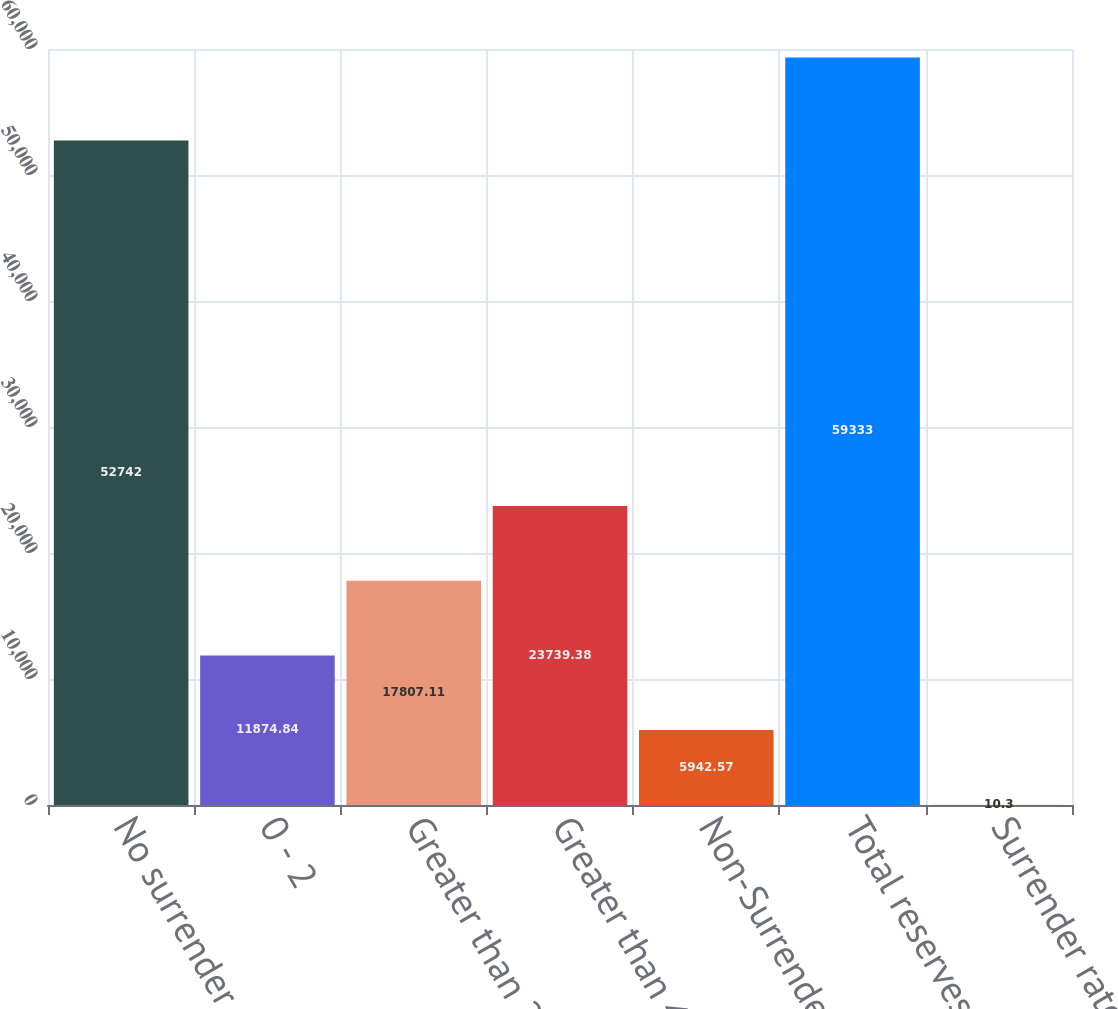Convert chart. <chart><loc_0><loc_0><loc_500><loc_500><bar_chart><fcel>No surrender charge<fcel>0 - 2<fcel>Greater than 2 - 4<fcel>Greater than 4<fcel>Non-Surrenderable<fcel>Total reserves<fcel>Surrender rates<nl><fcel>52742<fcel>11874.8<fcel>17807.1<fcel>23739.4<fcel>5942.57<fcel>59333<fcel>10.3<nl></chart> 